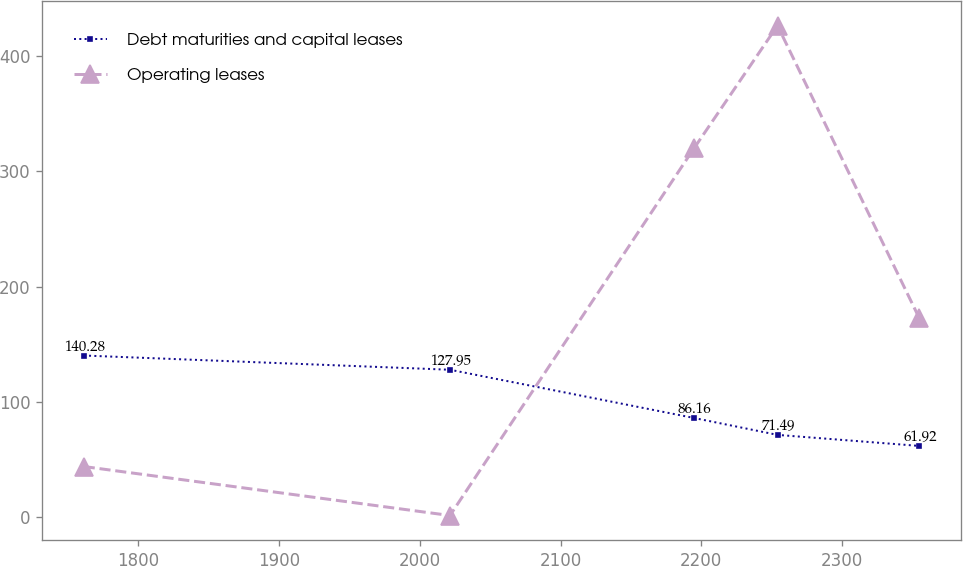Convert chart to OTSL. <chart><loc_0><loc_0><loc_500><loc_500><line_chart><ecel><fcel>Debt maturities and capital leases<fcel>Operating leases<nl><fcel>1761.18<fcel>140.28<fcel>44.08<nl><fcel>2021.4<fcel>127.95<fcel>1.62<nl><fcel>2194.81<fcel>86.16<fcel>319.8<nl><fcel>2254.19<fcel>71.49<fcel>426.21<nl><fcel>2355.01<fcel>61.92<fcel>172.44<nl></chart> 